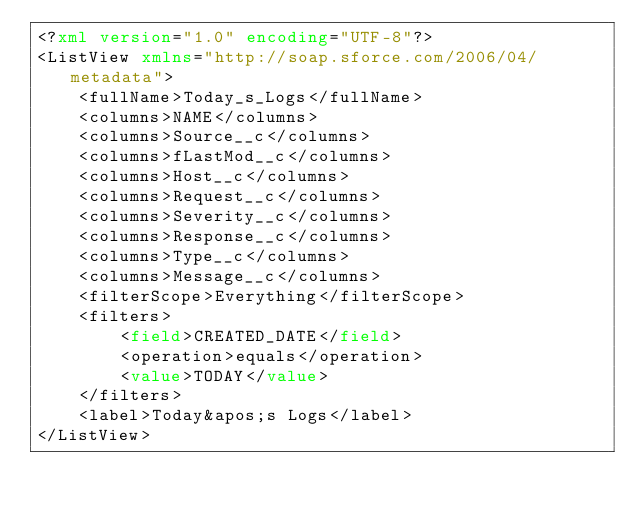<code> <loc_0><loc_0><loc_500><loc_500><_XML_><?xml version="1.0" encoding="UTF-8"?>
<ListView xmlns="http://soap.sforce.com/2006/04/metadata">
    <fullName>Today_s_Logs</fullName>
    <columns>NAME</columns>
    <columns>Source__c</columns>
    <columns>fLastMod__c</columns>
    <columns>Host__c</columns>
    <columns>Request__c</columns>
    <columns>Severity__c</columns>
    <columns>Response__c</columns>
    <columns>Type__c</columns>
    <columns>Message__c</columns>
    <filterScope>Everything</filterScope>
    <filters>
        <field>CREATED_DATE</field>
        <operation>equals</operation>
        <value>TODAY</value>
    </filters>
    <label>Today&apos;s Logs</label>
</ListView>
</code> 